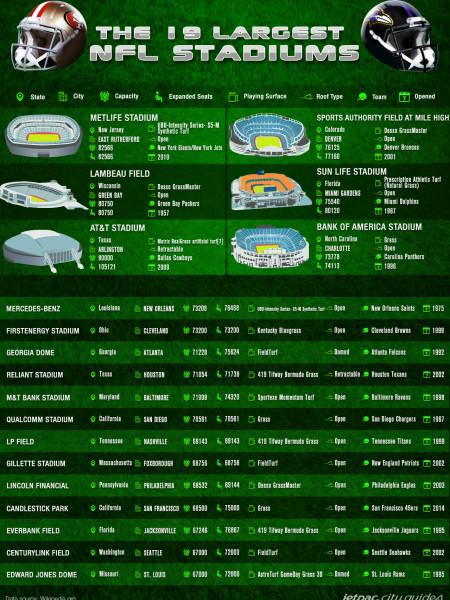List a handful of essential elements in this visual. The infographic contains six images of stadiums. The stadium shown in the second picture is named Sports Authority Field at Mile High. There are 13 stadium names listed without pictures. The stadium mentioned in the second-to-last row of the list is CenturyLink Field. The third image depicts a stadium that is known as Lambeau Field. 